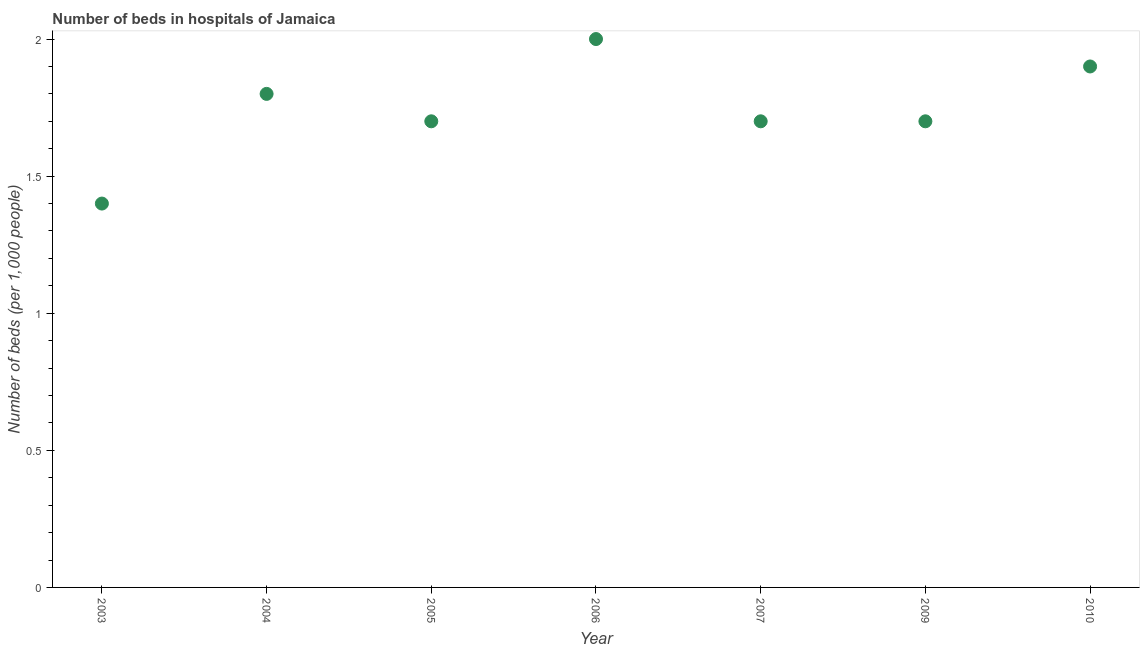Across all years, what is the minimum number of hospital beds?
Provide a succinct answer. 1.4. In which year was the number of hospital beds minimum?
Offer a very short reply. 2003. What is the sum of the number of hospital beds?
Provide a succinct answer. 12.2. What is the difference between the number of hospital beds in 2005 and 2009?
Offer a terse response. 0. What is the average number of hospital beds per year?
Keep it short and to the point. 1.74. What is the median number of hospital beds?
Ensure brevity in your answer.  1.7. In how many years, is the number of hospital beds greater than 0.8 %?
Offer a very short reply. 7. Do a majority of the years between 2005 and 2006 (inclusive) have number of hospital beds greater than 0.1 %?
Ensure brevity in your answer.  Yes. What is the ratio of the number of hospital beds in 2009 to that in 2010?
Give a very brief answer. 0.89. What is the difference between the highest and the second highest number of hospital beds?
Offer a terse response. 0.1. What is the difference between the highest and the lowest number of hospital beds?
Your answer should be compact. 0.6. In how many years, is the number of hospital beds greater than the average number of hospital beds taken over all years?
Make the answer very short. 3. How many dotlines are there?
Your response must be concise. 1. Are the values on the major ticks of Y-axis written in scientific E-notation?
Your response must be concise. No. Does the graph contain grids?
Give a very brief answer. No. What is the title of the graph?
Offer a very short reply. Number of beds in hospitals of Jamaica. What is the label or title of the X-axis?
Offer a very short reply. Year. What is the label or title of the Y-axis?
Your answer should be very brief. Number of beds (per 1,0 people). What is the Number of beds (per 1,000 people) in 2003?
Your response must be concise. 1.4. What is the Number of beds (per 1,000 people) in 2004?
Make the answer very short. 1.8. What is the Number of beds (per 1,000 people) in 2006?
Your answer should be compact. 2. What is the Number of beds (per 1,000 people) in 2007?
Your answer should be compact. 1.7. What is the difference between the Number of beds (per 1,000 people) in 2003 and 2005?
Your response must be concise. -0.3. What is the difference between the Number of beds (per 1,000 people) in 2003 and 2006?
Provide a short and direct response. -0.6. What is the difference between the Number of beds (per 1,000 people) in 2003 and 2007?
Offer a terse response. -0.3. What is the difference between the Number of beds (per 1,000 people) in 2003 and 2009?
Your answer should be compact. -0.3. What is the difference between the Number of beds (per 1,000 people) in 2004 and 2005?
Provide a succinct answer. 0.1. What is the difference between the Number of beds (per 1,000 people) in 2004 and 2006?
Provide a short and direct response. -0.2. What is the difference between the Number of beds (per 1,000 people) in 2005 and 2006?
Provide a short and direct response. -0.3. What is the difference between the Number of beds (per 1,000 people) in 2005 and 2007?
Make the answer very short. 0. What is the difference between the Number of beds (per 1,000 people) in 2005 and 2009?
Make the answer very short. 0. What is the difference between the Number of beds (per 1,000 people) in 2005 and 2010?
Keep it short and to the point. -0.2. What is the difference between the Number of beds (per 1,000 people) in 2006 and 2007?
Give a very brief answer. 0.3. What is the difference between the Number of beds (per 1,000 people) in 2006 and 2009?
Keep it short and to the point. 0.3. What is the difference between the Number of beds (per 1,000 people) in 2006 and 2010?
Offer a terse response. 0.1. What is the difference between the Number of beds (per 1,000 people) in 2009 and 2010?
Keep it short and to the point. -0.2. What is the ratio of the Number of beds (per 1,000 people) in 2003 to that in 2004?
Your answer should be compact. 0.78. What is the ratio of the Number of beds (per 1,000 people) in 2003 to that in 2005?
Your answer should be compact. 0.82. What is the ratio of the Number of beds (per 1,000 people) in 2003 to that in 2006?
Make the answer very short. 0.7. What is the ratio of the Number of beds (per 1,000 people) in 2003 to that in 2007?
Your answer should be very brief. 0.82. What is the ratio of the Number of beds (per 1,000 people) in 2003 to that in 2009?
Your answer should be very brief. 0.82. What is the ratio of the Number of beds (per 1,000 people) in 2003 to that in 2010?
Give a very brief answer. 0.74. What is the ratio of the Number of beds (per 1,000 people) in 2004 to that in 2005?
Ensure brevity in your answer.  1.06. What is the ratio of the Number of beds (per 1,000 people) in 2004 to that in 2007?
Give a very brief answer. 1.06. What is the ratio of the Number of beds (per 1,000 people) in 2004 to that in 2009?
Offer a very short reply. 1.06. What is the ratio of the Number of beds (per 1,000 people) in 2004 to that in 2010?
Provide a succinct answer. 0.95. What is the ratio of the Number of beds (per 1,000 people) in 2005 to that in 2007?
Provide a short and direct response. 1. What is the ratio of the Number of beds (per 1,000 people) in 2005 to that in 2009?
Make the answer very short. 1. What is the ratio of the Number of beds (per 1,000 people) in 2005 to that in 2010?
Ensure brevity in your answer.  0.9. What is the ratio of the Number of beds (per 1,000 people) in 2006 to that in 2007?
Provide a short and direct response. 1.18. What is the ratio of the Number of beds (per 1,000 people) in 2006 to that in 2009?
Make the answer very short. 1.18. What is the ratio of the Number of beds (per 1,000 people) in 2006 to that in 2010?
Your answer should be compact. 1.05. What is the ratio of the Number of beds (per 1,000 people) in 2007 to that in 2009?
Ensure brevity in your answer.  1. What is the ratio of the Number of beds (per 1,000 people) in 2007 to that in 2010?
Your response must be concise. 0.9. What is the ratio of the Number of beds (per 1,000 people) in 2009 to that in 2010?
Provide a succinct answer. 0.9. 